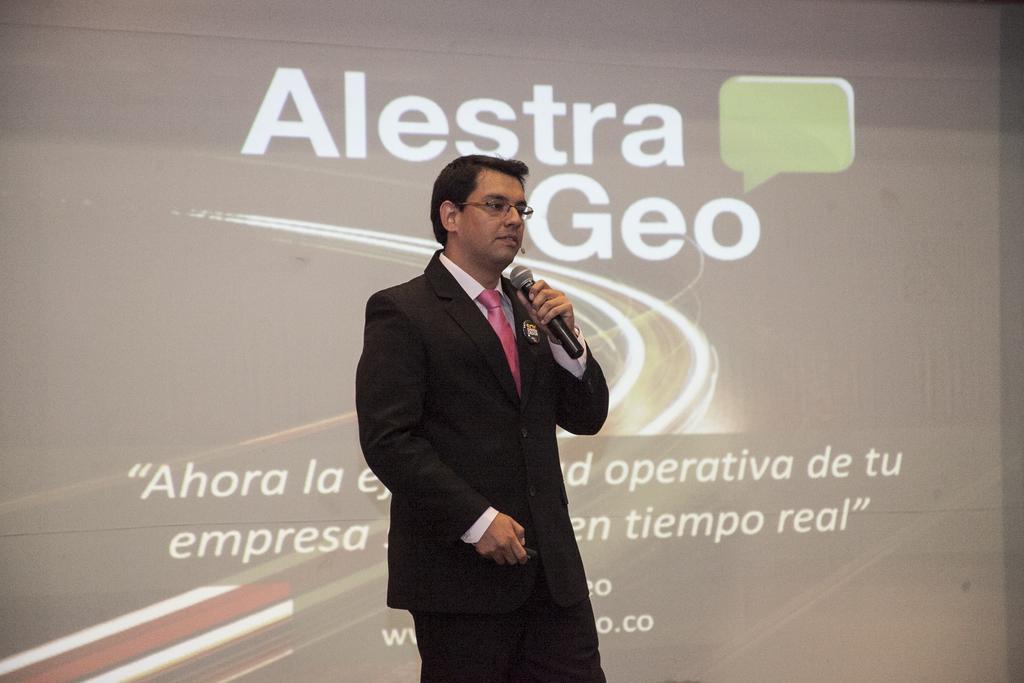Please provide a concise description of this image. As we can see in the image there is screen, a man wearing black color jacket and holding mic. On screen there is something written. 